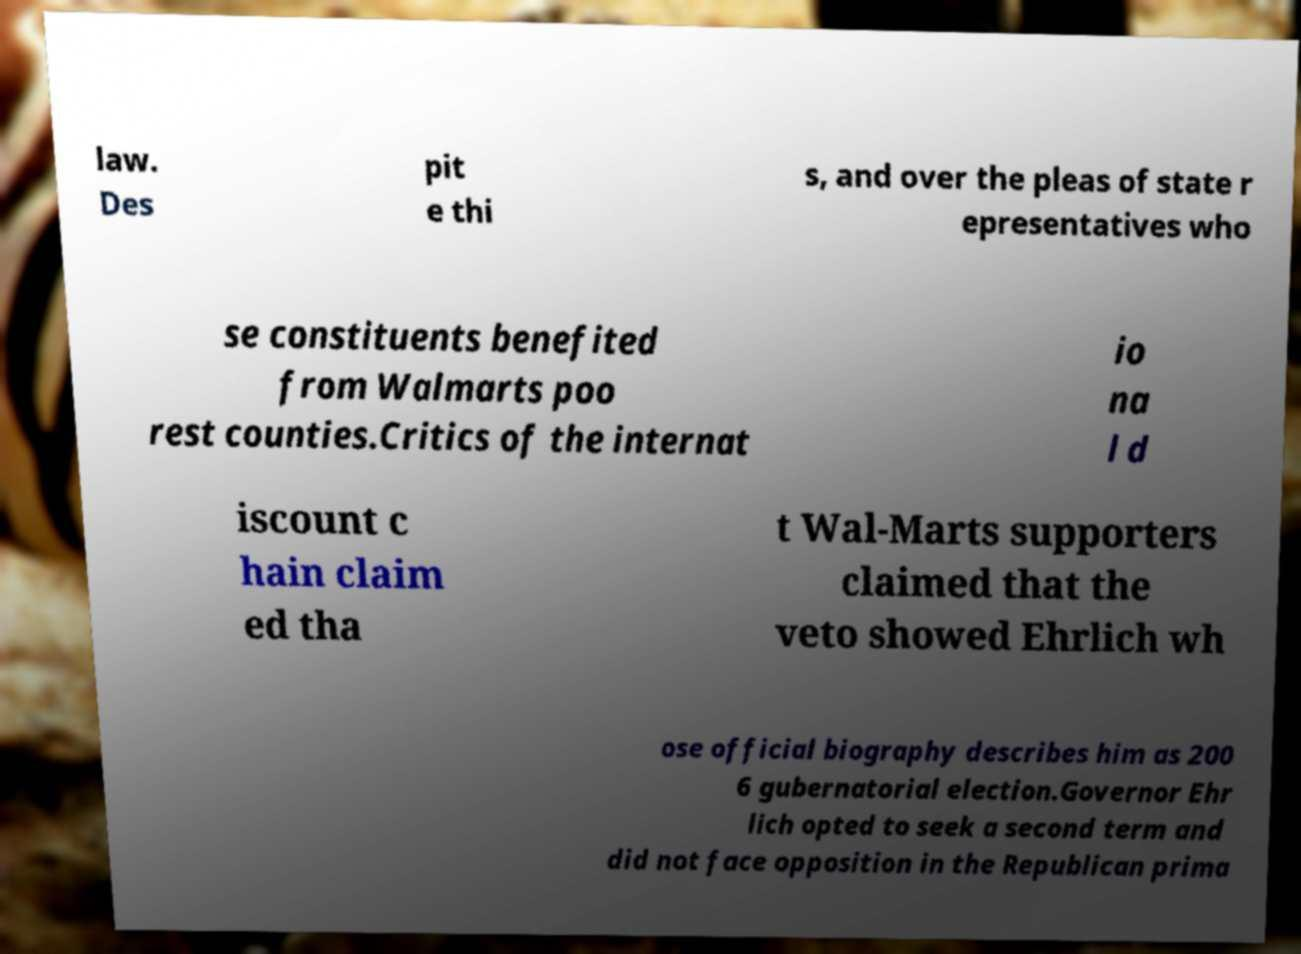Please read and relay the text visible in this image. What does it say? law. Des pit e thi s, and over the pleas of state r epresentatives who se constituents benefited from Walmarts poo rest counties.Critics of the internat io na l d iscount c hain claim ed tha t Wal-Marts supporters claimed that the veto showed Ehrlich wh ose official biography describes him as 200 6 gubernatorial election.Governor Ehr lich opted to seek a second term and did not face opposition in the Republican prima 